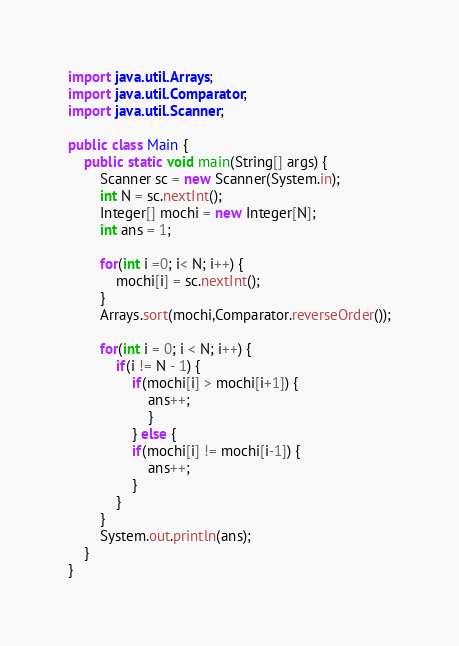<code> <loc_0><loc_0><loc_500><loc_500><_Java_>import java.util.Arrays;
import java.util.Comparator;
import java.util.Scanner;

public class Main {
	public static void main(String[] args) {
		Scanner sc = new Scanner(System.in);
		int N = sc.nextInt();
		Integer[] mochi = new Integer[N];
		int ans = 1;
		
		for(int i =0; i< N; i++) {
			mochi[i] = sc.nextInt();
		}
		Arrays.sort(mochi,Comparator.reverseOrder());
		
		for(int i = 0; i < N; i++) {
			if(i != N - 1) {
				if(mochi[i] > mochi[i+1]) {
					ans++;
					}
				} else {
				if(mochi[i] != mochi[i-1]) {
					ans++;
				}
			}
		}
		System.out.println(ans);
	}
}</code> 